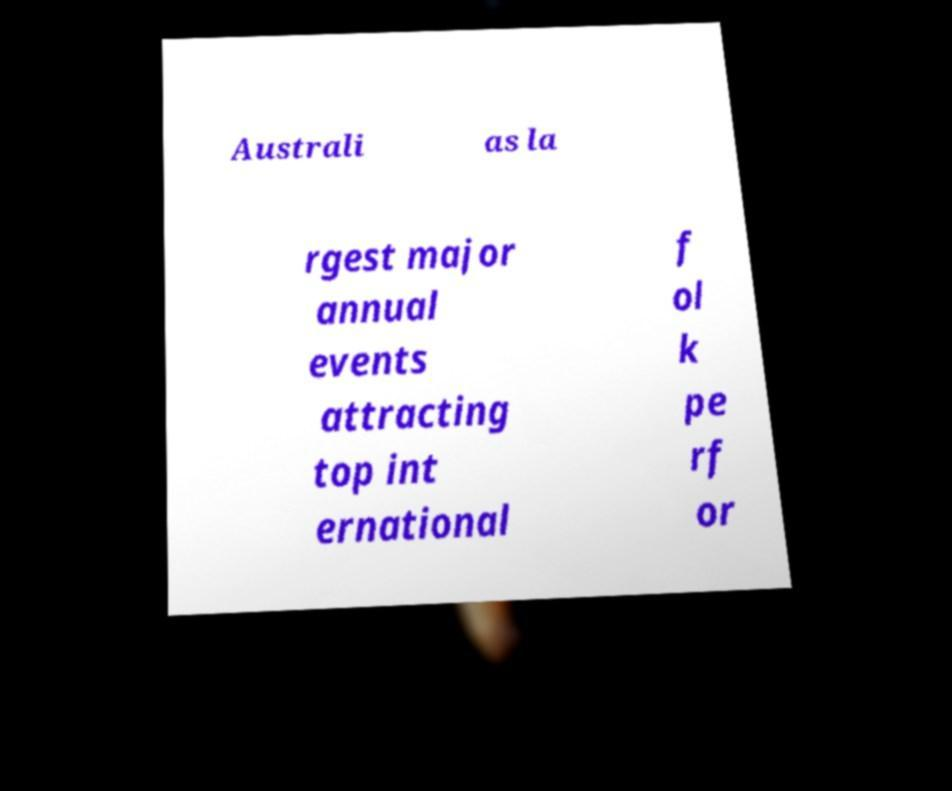Can you read and provide the text displayed in the image?This photo seems to have some interesting text. Can you extract and type it out for me? Australi as la rgest major annual events attracting top int ernational f ol k pe rf or 